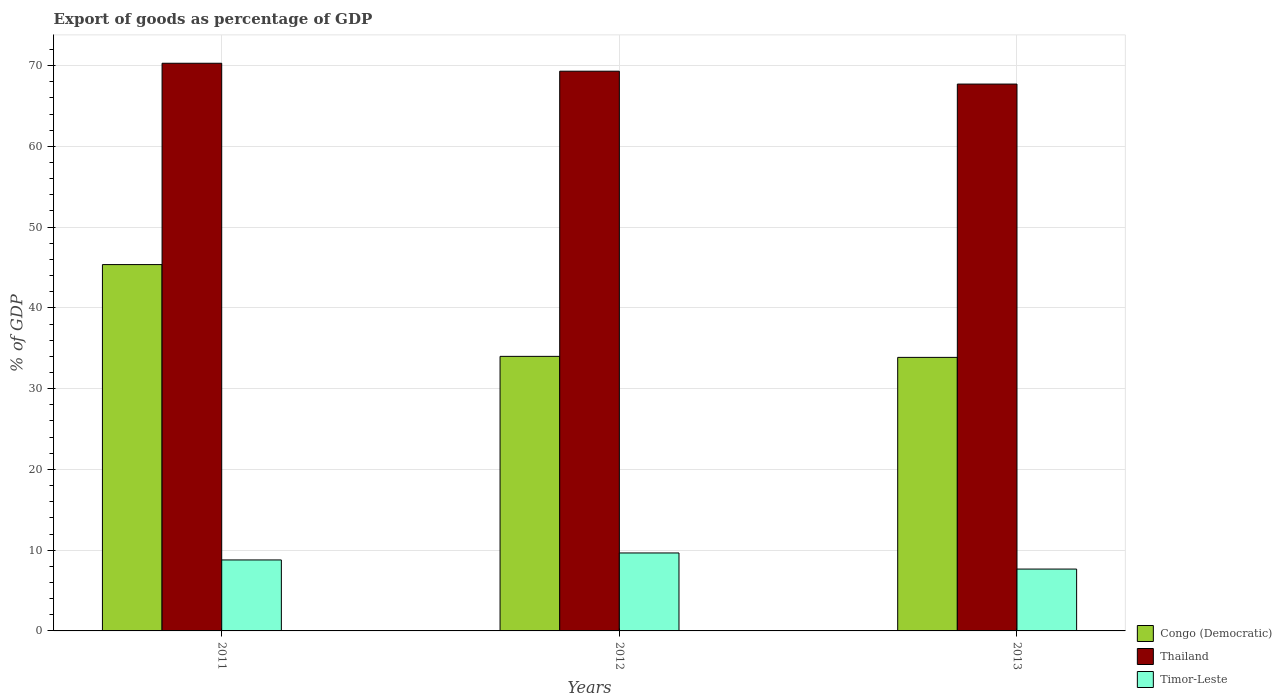How many different coloured bars are there?
Provide a short and direct response. 3. How many bars are there on the 1st tick from the left?
Ensure brevity in your answer.  3. How many bars are there on the 1st tick from the right?
Make the answer very short. 3. What is the label of the 1st group of bars from the left?
Ensure brevity in your answer.  2011. What is the export of goods as percentage of GDP in Congo (Democratic) in 2013?
Offer a very short reply. 33.87. Across all years, what is the maximum export of goods as percentage of GDP in Timor-Leste?
Offer a terse response. 9.65. Across all years, what is the minimum export of goods as percentage of GDP in Congo (Democratic)?
Provide a short and direct response. 33.87. In which year was the export of goods as percentage of GDP in Congo (Democratic) maximum?
Your response must be concise. 2011. What is the total export of goods as percentage of GDP in Congo (Democratic) in the graph?
Offer a very short reply. 113.22. What is the difference between the export of goods as percentage of GDP in Timor-Leste in 2011 and that in 2012?
Keep it short and to the point. -0.87. What is the difference between the export of goods as percentage of GDP in Timor-Leste in 2012 and the export of goods as percentage of GDP in Congo (Democratic) in 2013?
Give a very brief answer. -24.22. What is the average export of goods as percentage of GDP in Timor-Leste per year?
Make the answer very short. 8.7. In the year 2011, what is the difference between the export of goods as percentage of GDP in Congo (Democratic) and export of goods as percentage of GDP in Thailand?
Your answer should be very brief. -24.93. In how many years, is the export of goods as percentage of GDP in Timor-Leste greater than 16 %?
Give a very brief answer. 0. What is the ratio of the export of goods as percentage of GDP in Thailand in 2012 to that in 2013?
Give a very brief answer. 1.02. Is the export of goods as percentage of GDP in Timor-Leste in 2011 less than that in 2012?
Your answer should be very brief. Yes. What is the difference between the highest and the second highest export of goods as percentage of GDP in Congo (Democratic)?
Provide a succinct answer. 11.36. What is the difference between the highest and the lowest export of goods as percentage of GDP in Timor-Leste?
Your answer should be very brief. 2. In how many years, is the export of goods as percentage of GDP in Timor-Leste greater than the average export of goods as percentage of GDP in Timor-Leste taken over all years?
Give a very brief answer. 2. Is the sum of the export of goods as percentage of GDP in Thailand in 2011 and 2013 greater than the maximum export of goods as percentage of GDP in Congo (Democratic) across all years?
Your response must be concise. Yes. What does the 1st bar from the left in 2013 represents?
Your answer should be very brief. Congo (Democratic). What does the 2nd bar from the right in 2012 represents?
Your answer should be compact. Thailand. Are all the bars in the graph horizontal?
Offer a very short reply. No. How many years are there in the graph?
Make the answer very short. 3. Does the graph contain grids?
Make the answer very short. Yes. How are the legend labels stacked?
Provide a short and direct response. Vertical. What is the title of the graph?
Give a very brief answer. Export of goods as percentage of GDP. What is the label or title of the Y-axis?
Give a very brief answer. % of GDP. What is the % of GDP of Congo (Democratic) in 2011?
Give a very brief answer. 45.36. What is the % of GDP in Thailand in 2011?
Provide a succinct answer. 70.29. What is the % of GDP of Timor-Leste in 2011?
Provide a short and direct response. 8.79. What is the % of GDP of Congo (Democratic) in 2012?
Give a very brief answer. 34. What is the % of GDP in Thailand in 2012?
Keep it short and to the point. 69.3. What is the % of GDP in Timor-Leste in 2012?
Provide a short and direct response. 9.65. What is the % of GDP in Congo (Democratic) in 2013?
Keep it short and to the point. 33.87. What is the % of GDP in Thailand in 2013?
Ensure brevity in your answer.  67.71. What is the % of GDP in Timor-Leste in 2013?
Offer a very short reply. 7.66. Across all years, what is the maximum % of GDP in Congo (Democratic)?
Make the answer very short. 45.36. Across all years, what is the maximum % of GDP of Thailand?
Provide a succinct answer. 70.29. Across all years, what is the maximum % of GDP in Timor-Leste?
Your answer should be compact. 9.65. Across all years, what is the minimum % of GDP in Congo (Democratic)?
Provide a short and direct response. 33.87. Across all years, what is the minimum % of GDP in Thailand?
Provide a succinct answer. 67.71. Across all years, what is the minimum % of GDP of Timor-Leste?
Your response must be concise. 7.66. What is the total % of GDP in Congo (Democratic) in the graph?
Offer a terse response. 113.22. What is the total % of GDP in Thailand in the graph?
Keep it short and to the point. 207.3. What is the total % of GDP of Timor-Leste in the graph?
Your response must be concise. 26.1. What is the difference between the % of GDP in Congo (Democratic) in 2011 and that in 2012?
Your answer should be compact. 11.36. What is the difference between the % of GDP of Thailand in 2011 and that in 2012?
Your response must be concise. 0.98. What is the difference between the % of GDP of Timor-Leste in 2011 and that in 2012?
Give a very brief answer. -0.87. What is the difference between the % of GDP of Congo (Democratic) in 2011 and that in 2013?
Give a very brief answer. 11.49. What is the difference between the % of GDP in Thailand in 2011 and that in 2013?
Keep it short and to the point. 2.58. What is the difference between the % of GDP in Timor-Leste in 2011 and that in 2013?
Offer a terse response. 1.13. What is the difference between the % of GDP of Congo (Democratic) in 2012 and that in 2013?
Give a very brief answer. 0.13. What is the difference between the % of GDP in Thailand in 2012 and that in 2013?
Your answer should be very brief. 1.59. What is the difference between the % of GDP in Timor-Leste in 2012 and that in 2013?
Offer a very short reply. 2. What is the difference between the % of GDP of Congo (Democratic) in 2011 and the % of GDP of Thailand in 2012?
Provide a succinct answer. -23.94. What is the difference between the % of GDP in Congo (Democratic) in 2011 and the % of GDP in Timor-Leste in 2012?
Your answer should be compact. 35.71. What is the difference between the % of GDP of Thailand in 2011 and the % of GDP of Timor-Leste in 2012?
Your answer should be compact. 60.63. What is the difference between the % of GDP in Congo (Democratic) in 2011 and the % of GDP in Thailand in 2013?
Make the answer very short. -22.35. What is the difference between the % of GDP of Congo (Democratic) in 2011 and the % of GDP of Timor-Leste in 2013?
Give a very brief answer. 37.7. What is the difference between the % of GDP in Thailand in 2011 and the % of GDP in Timor-Leste in 2013?
Offer a very short reply. 62.63. What is the difference between the % of GDP of Congo (Democratic) in 2012 and the % of GDP of Thailand in 2013?
Offer a very short reply. -33.71. What is the difference between the % of GDP of Congo (Democratic) in 2012 and the % of GDP of Timor-Leste in 2013?
Ensure brevity in your answer.  26.34. What is the difference between the % of GDP of Thailand in 2012 and the % of GDP of Timor-Leste in 2013?
Give a very brief answer. 61.65. What is the average % of GDP of Congo (Democratic) per year?
Ensure brevity in your answer.  37.74. What is the average % of GDP in Thailand per year?
Your response must be concise. 69.1. What is the average % of GDP of Timor-Leste per year?
Offer a very short reply. 8.7. In the year 2011, what is the difference between the % of GDP of Congo (Democratic) and % of GDP of Thailand?
Your answer should be very brief. -24.93. In the year 2011, what is the difference between the % of GDP in Congo (Democratic) and % of GDP in Timor-Leste?
Your response must be concise. 36.57. In the year 2011, what is the difference between the % of GDP in Thailand and % of GDP in Timor-Leste?
Your answer should be compact. 61.5. In the year 2012, what is the difference between the % of GDP in Congo (Democratic) and % of GDP in Thailand?
Make the answer very short. -35.31. In the year 2012, what is the difference between the % of GDP of Congo (Democratic) and % of GDP of Timor-Leste?
Your answer should be compact. 24.34. In the year 2012, what is the difference between the % of GDP in Thailand and % of GDP in Timor-Leste?
Your answer should be compact. 59.65. In the year 2013, what is the difference between the % of GDP in Congo (Democratic) and % of GDP in Thailand?
Your response must be concise. -33.84. In the year 2013, what is the difference between the % of GDP of Congo (Democratic) and % of GDP of Timor-Leste?
Your answer should be compact. 26.21. In the year 2013, what is the difference between the % of GDP of Thailand and % of GDP of Timor-Leste?
Your answer should be compact. 60.05. What is the ratio of the % of GDP of Congo (Democratic) in 2011 to that in 2012?
Your answer should be compact. 1.33. What is the ratio of the % of GDP in Thailand in 2011 to that in 2012?
Offer a very short reply. 1.01. What is the ratio of the % of GDP in Timor-Leste in 2011 to that in 2012?
Keep it short and to the point. 0.91. What is the ratio of the % of GDP in Congo (Democratic) in 2011 to that in 2013?
Your response must be concise. 1.34. What is the ratio of the % of GDP of Thailand in 2011 to that in 2013?
Provide a short and direct response. 1.04. What is the ratio of the % of GDP of Timor-Leste in 2011 to that in 2013?
Offer a very short reply. 1.15. What is the ratio of the % of GDP in Thailand in 2012 to that in 2013?
Ensure brevity in your answer.  1.02. What is the ratio of the % of GDP of Timor-Leste in 2012 to that in 2013?
Provide a succinct answer. 1.26. What is the difference between the highest and the second highest % of GDP of Congo (Democratic)?
Keep it short and to the point. 11.36. What is the difference between the highest and the second highest % of GDP in Thailand?
Keep it short and to the point. 0.98. What is the difference between the highest and the second highest % of GDP of Timor-Leste?
Your response must be concise. 0.87. What is the difference between the highest and the lowest % of GDP of Congo (Democratic)?
Your response must be concise. 11.49. What is the difference between the highest and the lowest % of GDP in Thailand?
Provide a short and direct response. 2.58. What is the difference between the highest and the lowest % of GDP of Timor-Leste?
Provide a succinct answer. 2. 